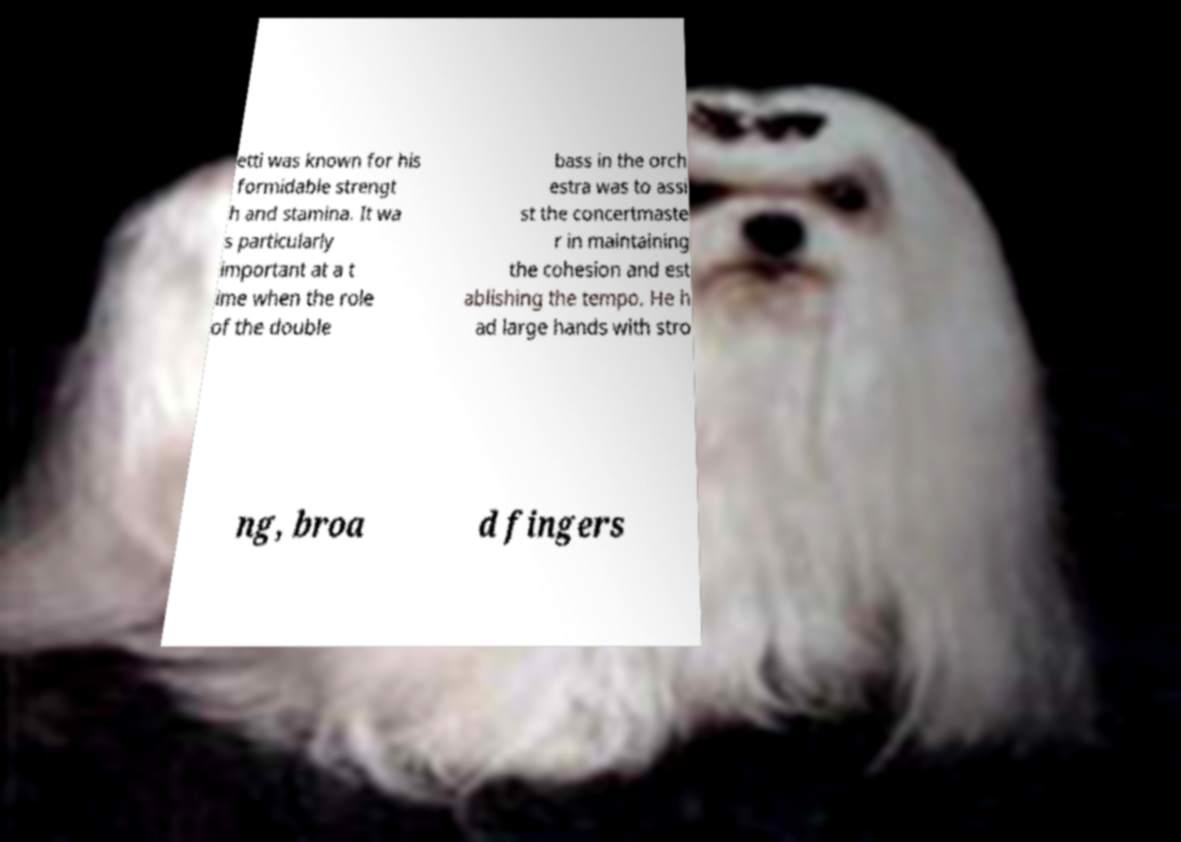I need the written content from this picture converted into text. Can you do that? etti was known for his formidable strengt h and stamina. It wa s particularly important at a t ime when the role of the double bass in the orch estra was to assi st the concertmaste r in maintaining the cohesion and est ablishing the tempo. He h ad large hands with stro ng, broa d fingers 